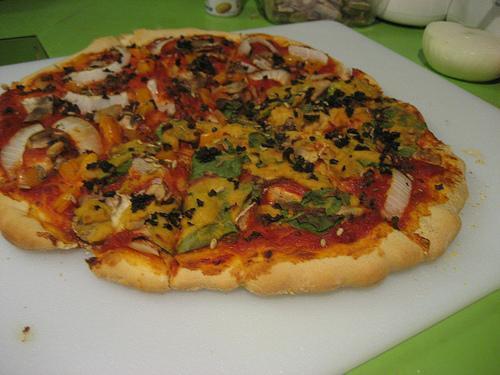How many pizzas are pictured?
Give a very brief answer. 1. 